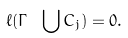Convert formula to latex. <formula><loc_0><loc_0><loc_500><loc_500>\ell ( \Gamma \ \bigcup C _ { j } ) = 0 .</formula> 